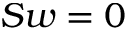Convert formula to latex. <formula><loc_0><loc_0><loc_500><loc_500>S w = 0</formula> 